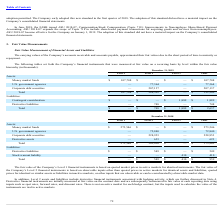According to Fitbit's financial document, What is the fair value of the Company's Level 1 financial instruments based on? Quoted market prices in active markets for identical instruments. The document states: "mpany’s Level 1 financial instruments is based on quoted market prices in active markets for identical instruments. The fair value of..." Also, What inputs are used to remeasure derivative financial instruments at each reporting date? Spot rates, forward rates, and discount rates.. The document states: "value at each reporting date using inputs such as spot rates, forward rates, and discount rates. There is not an active market for each hedge contract..." Also, What is the total liabilities for all levels as of December 31, 2018? According to the financial document, $959 (in thousands). The relevant text states: "Total $ — $ 549 $ 410 $ 959..." Also, can you calculate: What is the difference in the total assets between Level 1 and Level 2 as of December 31, 2019? Based on the calculation: $284,501- $107,708, the result is 176793 (in thousands). This is based on the information: "Total $ 107,708 $ 284,501 $ — $ 392,209 Money market funds $ 107,708 $ — $ — $ 107,708..." The key data points involved are: 107,708, 284,501. Also, can you calculate: What is the percentage constitution of money market funds among the total assets as of December 31, 2019? Based on the calculation: 107,708/392,209, the result is 27.46 (percentage). This is based on the information: "Total $ 107,708 $ 284,501 $ — $ 392,209 Money market funds $ 107,708 $ — $ — $ 107,708..." The key data points involved are: 107,708, 392,209. Also, can you calculate: What is the average total liabilities for 2018 and 2019? To answer this question, I need to perform calculations using the financial data. The calculation is: (2,637+959)/2, which equals 1798 (in thousands). This is based on the information: "Total $ — $ 549 $ 410 $ 959 Total $ — $ 748 $ 1,889 $ 2,637..." The key data points involved are: 2,637, 959. 